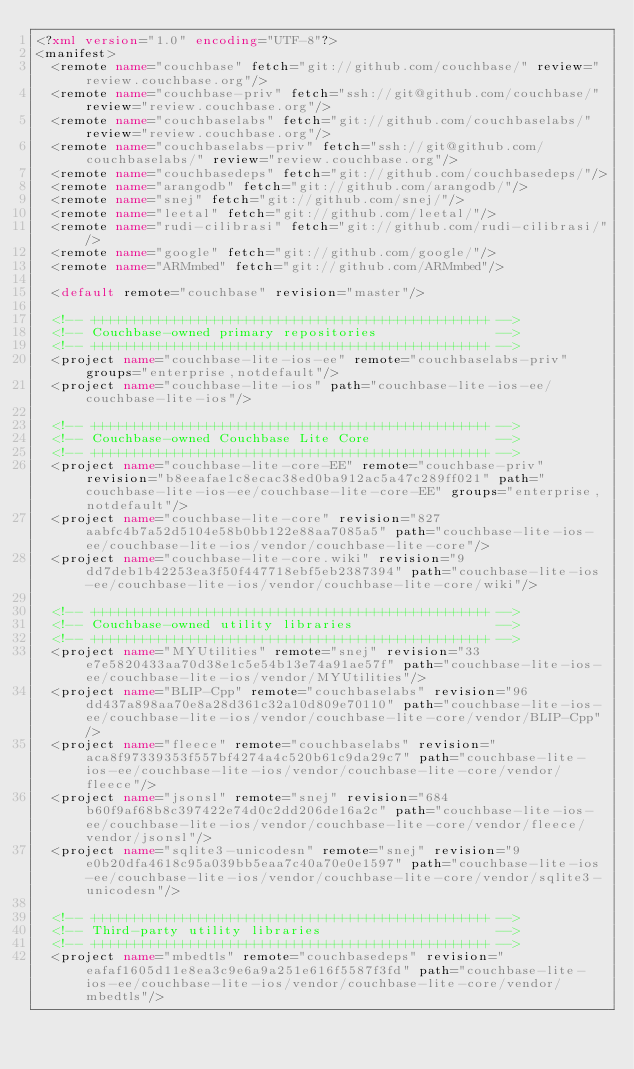Convert code to text. <code><loc_0><loc_0><loc_500><loc_500><_XML_><?xml version="1.0" encoding="UTF-8"?>
<manifest>
  <remote name="couchbase" fetch="git://github.com/couchbase/" review="review.couchbase.org"/>
  <remote name="couchbase-priv" fetch="ssh://git@github.com/couchbase/" review="review.couchbase.org"/>
  <remote name="couchbaselabs" fetch="git://github.com/couchbaselabs/" review="review.couchbase.org"/>
  <remote name="couchbaselabs-priv" fetch="ssh://git@github.com/couchbaselabs/" review="review.couchbase.org"/>
  <remote name="couchbasedeps" fetch="git://github.com/couchbasedeps/"/>
  <remote name="arangodb" fetch="git://github.com/arangodb/"/>
  <remote name="snej" fetch="git://github.com/snej/"/>
  <remote name="leetal" fetch="git://github.com/leetal/"/>
  <remote name="rudi-cilibrasi" fetch="git://github.com/rudi-cilibrasi/"/>
  <remote name="google" fetch="git://github.com/google/"/>
  <remote name="ARMmbed" fetch="git://github.com/ARMmbed"/>

  <default remote="couchbase" revision="master"/>

  <!-- ++++++++++++++++++++++++++++++++++++++++++++++++++ -->
  <!-- Couchbase-owned primary repositories               -->
  <!-- ++++++++++++++++++++++++++++++++++++++++++++++++++ -->
  <project name="couchbase-lite-ios-ee" remote="couchbaselabs-priv" groups="enterprise,notdefault"/>
  <project name="couchbase-lite-ios" path="couchbase-lite-ios-ee/couchbase-lite-ios"/>

  <!-- ++++++++++++++++++++++++++++++++++++++++++++++++++ -->
  <!-- Couchbase-owned Couchbase Lite Core                -->
  <!-- ++++++++++++++++++++++++++++++++++++++++++++++++++ -->
  <project name="couchbase-lite-core-EE" remote="couchbase-priv" revision="b8eeafae1c8ecac38ed0ba912ac5a47c289ff021" path="couchbase-lite-ios-ee/couchbase-lite-core-EE" groups="enterprise,notdefault"/>
  <project name="couchbase-lite-core" revision="827aabfc4b7a52d5104e58b0bb122e88aa7085a5" path="couchbase-lite-ios-ee/couchbase-lite-ios/vendor/couchbase-lite-core"/>
  <project name="couchbase-lite-core.wiki" revision="9dd7deb1b42253ea3f50f447718ebf5eb2387394" path="couchbase-lite-ios-ee/couchbase-lite-ios/vendor/couchbase-lite-core/wiki"/>

  <!-- ++++++++++++++++++++++++++++++++++++++++++++++++++ -->
  <!-- Couchbase-owned utility libraries                  -->
  <!-- ++++++++++++++++++++++++++++++++++++++++++++++++++ -->
  <project name="MYUtilities" remote="snej" revision="33e7e5820433aa70d38e1c5e54b13e74a91ae57f" path="couchbase-lite-ios-ee/couchbase-lite-ios/vendor/MYUtilities"/>
  <project name="BLIP-Cpp" remote="couchbaselabs" revision="96dd437a898aa70e8a28d361c32a10d809e70110" path="couchbase-lite-ios-ee/couchbase-lite-ios/vendor/couchbase-lite-core/vendor/BLIP-Cpp"/>
  <project name="fleece" remote="couchbaselabs" revision="aca8f97339353f557bf4274a4c520b61c9da29c7" path="couchbase-lite-ios-ee/couchbase-lite-ios/vendor/couchbase-lite-core/vendor/fleece"/>
  <project name="jsonsl" remote="snej" revision="684b60f9af68b8c397422e74d0c2dd206de16a2c" path="couchbase-lite-ios-ee/couchbase-lite-ios/vendor/couchbase-lite-core/vendor/fleece/vendor/jsonsl"/>
  <project name="sqlite3-unicodesn" remote="snej" revision="9e0b20dfa4618c95a039bb5eaa7c40a70e0e1597" path="couchbase-lite-ios-ee/couchbase-lite-ios/vendor/couchbase-lite-core/vendor/sqlite3-unicodesn"/>

  <!-- ++++++++++++++++++++++++++++++++++++++++++++++++++ -->
  <!-- Third-party utility libraries                      -->
  <!-- ++++++++++++++++++++++++++++++++++++++++++++++++++ -->
  <project name="mbedtls" remote="couchbasedeps" revision="eafaf1605d11e8ea3c9e6a9a251e616f5587f3fd" path="couchbase-lite-ios-ee/couchbase-lite-ios/vendor/couchbase-lite-core/vendor/mbedtls"/></code> 